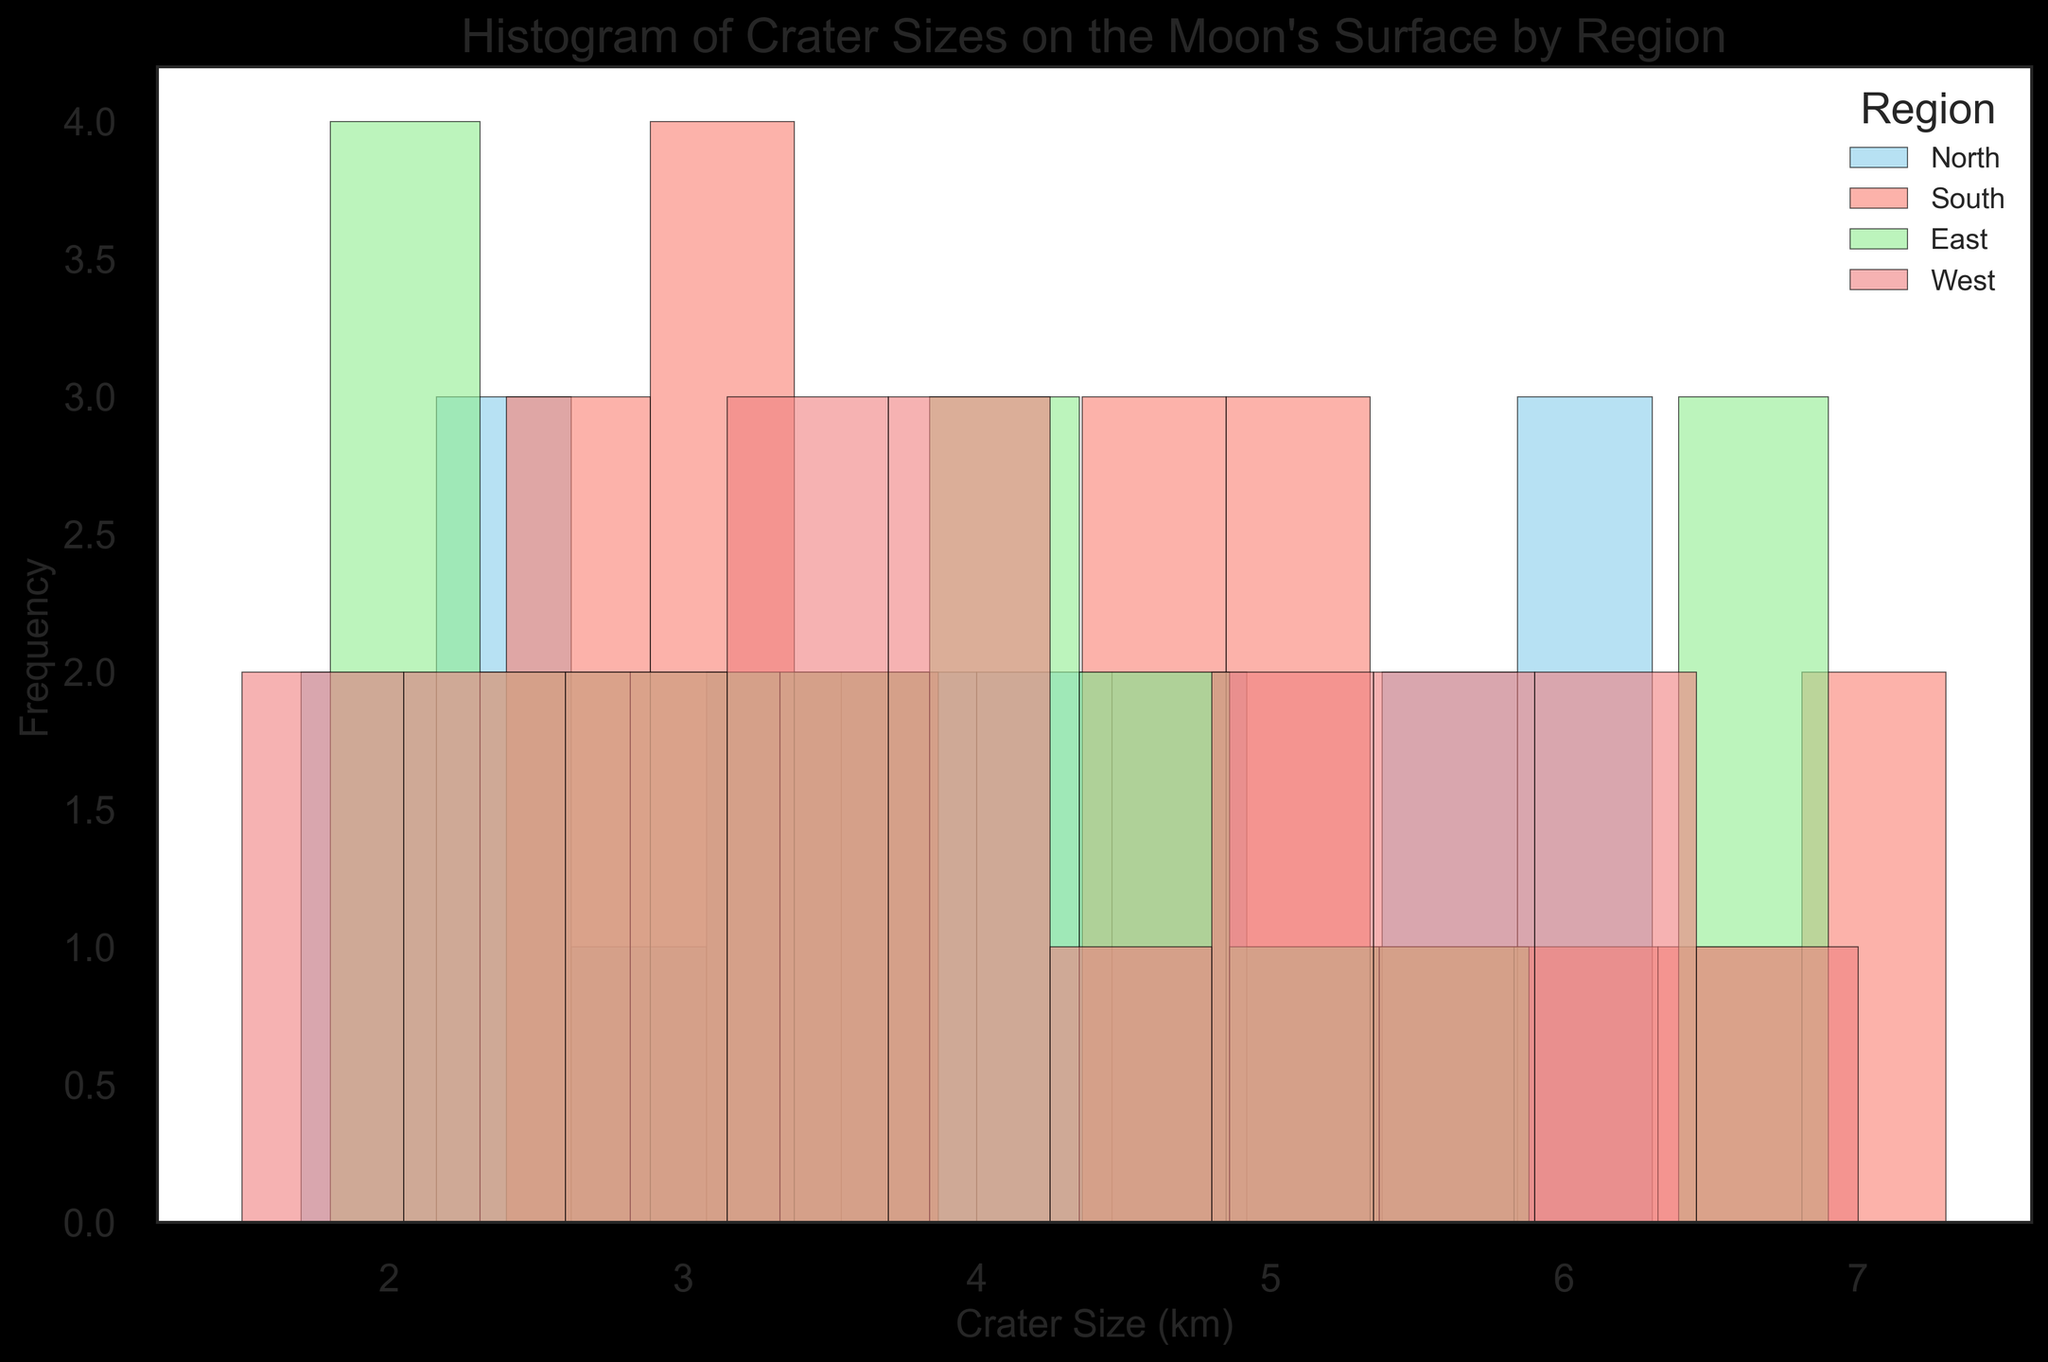What is the most frequent crater size range in the North region? To determine this, look at the bars representing the North region's crater sizes. The highest bar within the bins indicates the most frequent size range.
Answer: The 3-4 km range Which region has the largest number of craters in the 5-6 km size range? Identify the bar heights for the 5-6 km range for each region's color. Compare to see which bar is the tallest in this range.
Answer: East region What is the median crater size for the North region's craters? To find the median, list all crater sizes in the North region, sort them, and choose the middle value. If there’s an even number, average the two middle values.
Answer: 4.1 km How does the frequency of craters greater than 6 km compare between the North and South regions? Count the number of craters greater than 6 km in both regions and compare their frequencies.
Answer: More frequent in South Which region shows the most uniform distribution of crater sizes? Look for the region with bars that have similar heights, indicating a uniform distribution across different size ranges.
Answer: West region Do craters in the East region tend to be larger or smaller than those in the South region? Compare the peaks of the histograms for the East and South regions. Note where larger craters (right side of the histogram) are more frequent.
Answer: East tends to be larger What is the average crater size for the South region? List all sizes in the South region, sum them up, and divide by the total count.
Answer: 4.46 km Which region has the highest frequency of craters in the 2-3 km size range? Examine the heights of the bars within the 2-3 km range for each region and note the region with the tallest bar.
Answer: North region How many bins in the East region histogram contain more than 4 craters? Count the number of bins in the East region's histogram that have a height greater than 4.
Answer: Two bins Which regions have their largest frequency peak in a similar size range? Identify the size range with the highest bars for each region and then compare.
Answer: North and East regions 